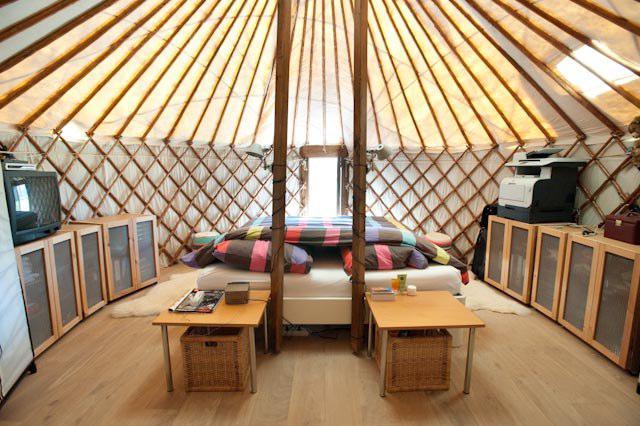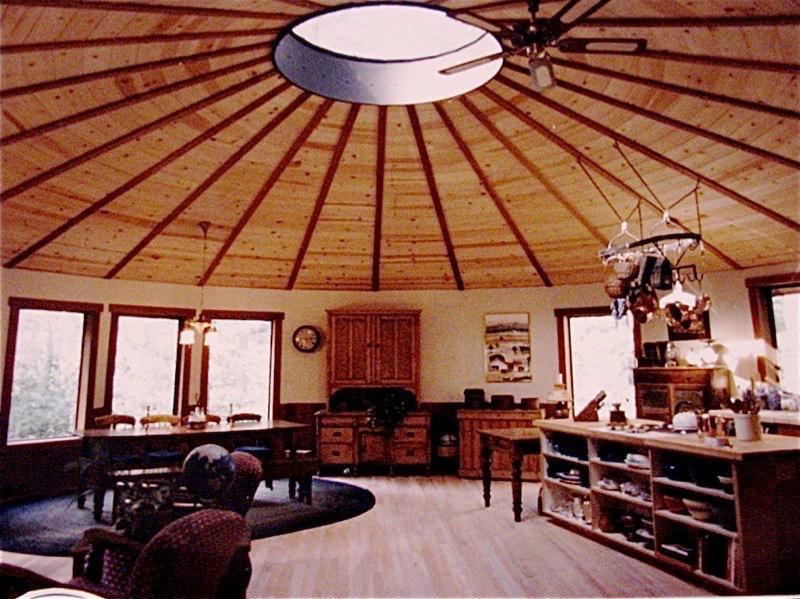The first image is the image on the left, the second image is the image on the right. Considering the images on both sides, is "At least one table is at the foot of the bed." valid? Answer yes or no. Yes. The first image is the image on the left, the second image is the image on the right. Analyze the images presented: Is the assertion "Both images are inside a yurt and the table in one of them is on top of a rug." valid? Answer yes or no. Yes. 